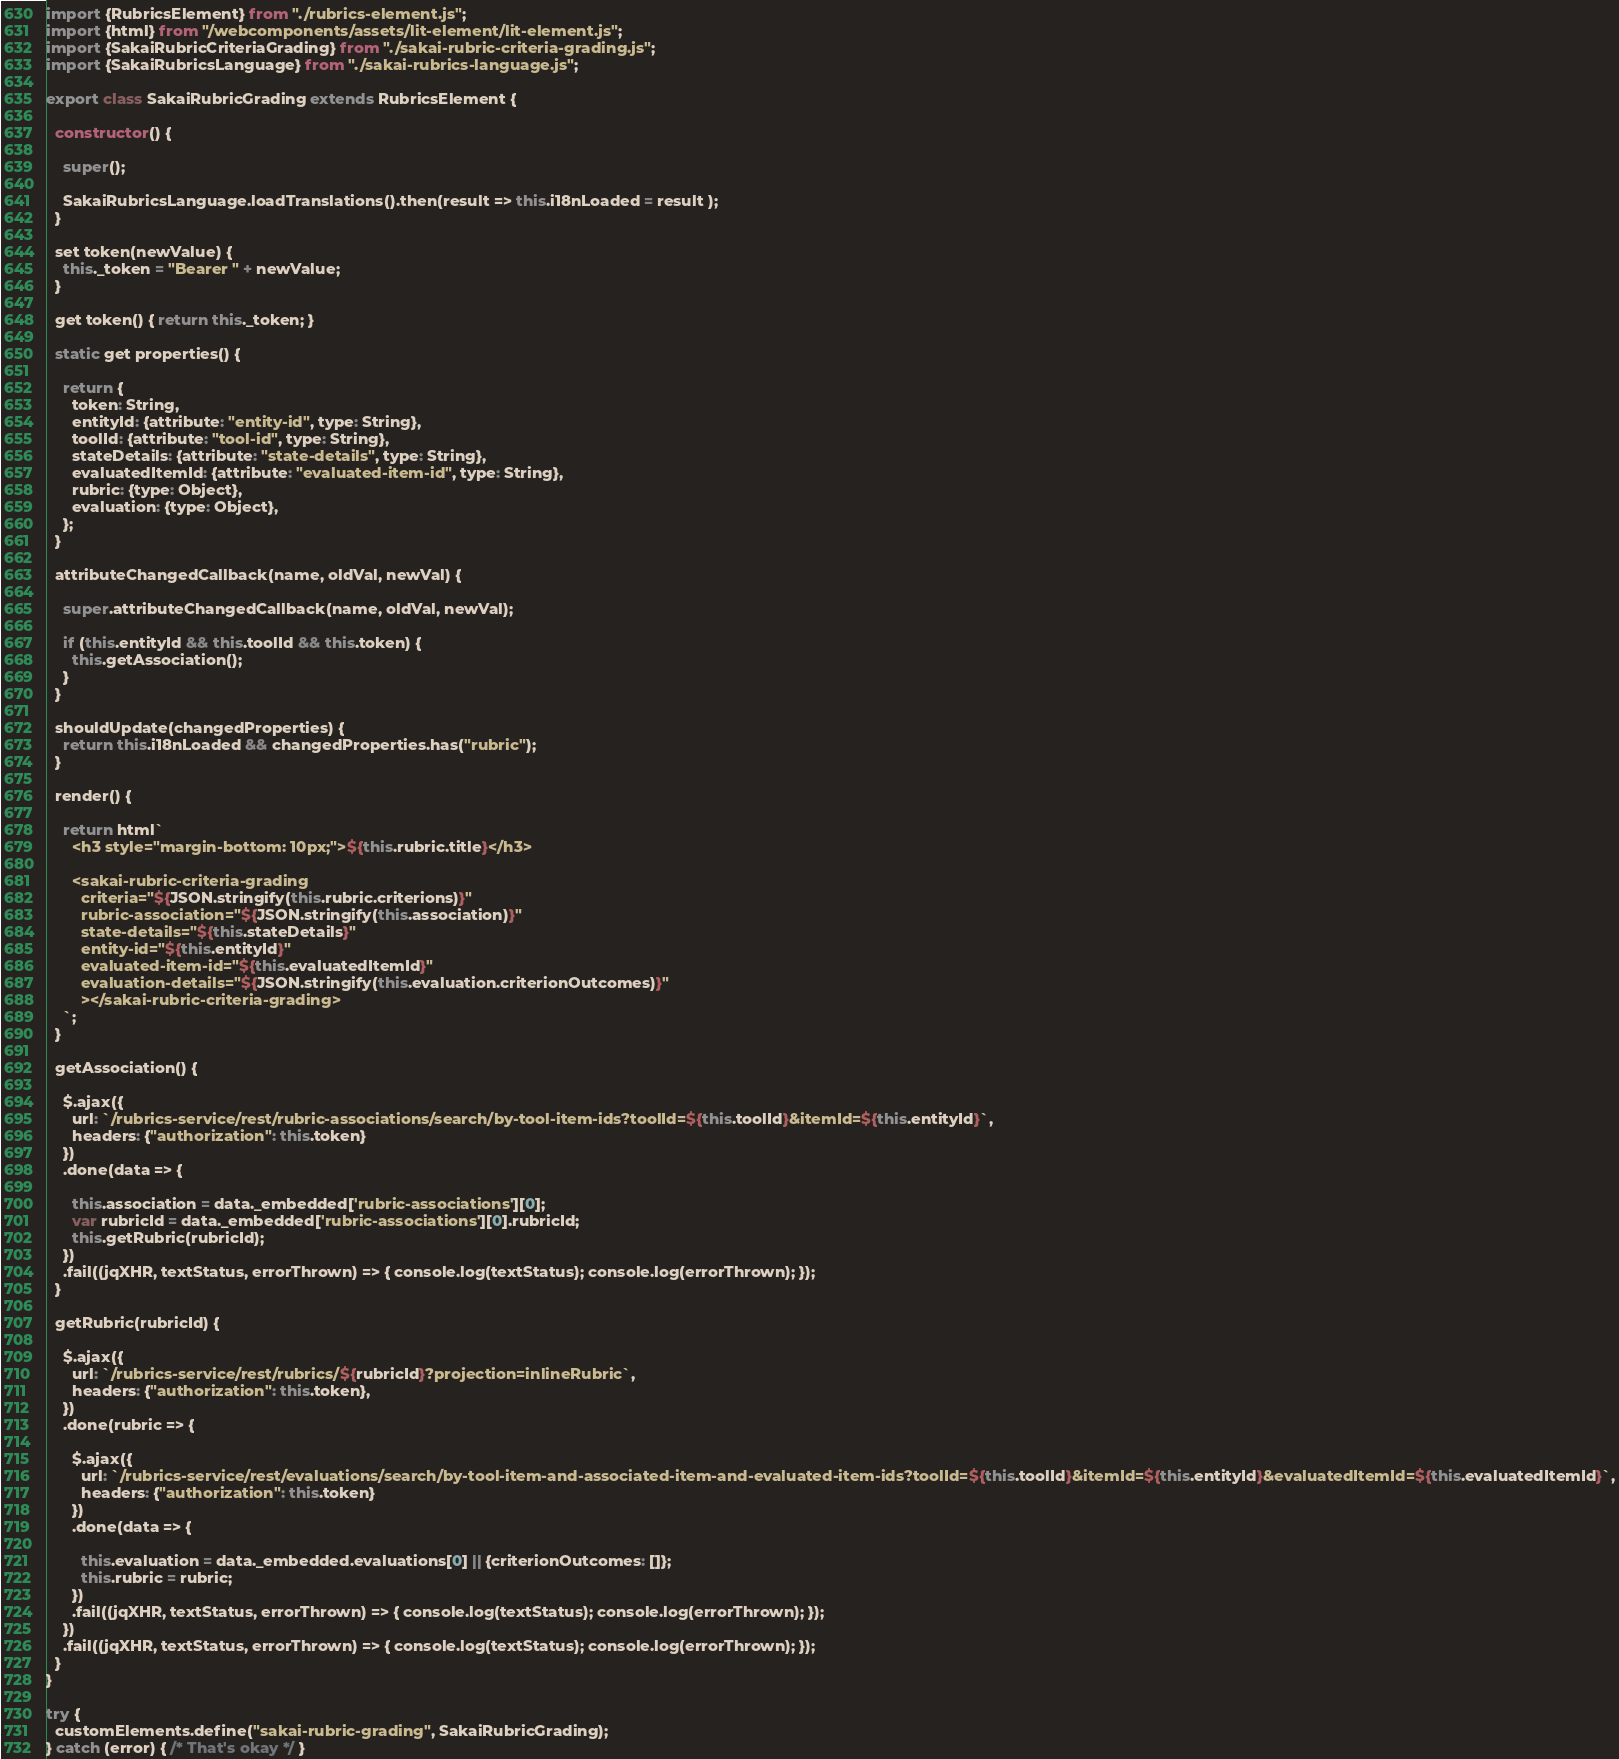Convert code to text. <code><loc_0><loc_0><loc_500><loc_500><_JavaScript_>import {RubricsElement} from "./rubrics-element.js";
import {html} from "/webcomponents/assets/lit-element/lit-element.js";
import {SakaiRubricCriteriaGrading} from "./sakai-rubric-criteria-grading.js";
import {SakaiRubricsLanguage} from "./sakai-rubrics-language.js";

export class SakaiRubricGrading extends RubricsElement {

  constructor() {

    super();

    SakaiRubricsLanguage.loadTranslations().then(result => this.i18nLoaded = result );
  }

  set token(newValue) {
    this._token = "Bearer " + newValue;
  }

  get token() { return this._token; }

  static get properties() {

    return {
      token: String,
      entityId: {attribute: "entity-id", type: String},
      toolId: {attribute: "tool-id", type: String},
      stateDetails: {attribute: "state-details", type: String},
      evaluatedItemId: {attribute: "evaluated-item-id", type: String},
      rubric: {type: Object},
      evaluation: {type: Object},
    };
  }

  attributeChangedCallback(name, oldVal, newVal) {

    super.attributeChangedCallback(name, oldVal, newVal);

    if (this.entityId && this.toolId && this.token) {
      this.getAssociation();
    }
  }

  shouldUpdate(changedProperties) {
    return this.i18nLoaded && changedProperties.has("rubric");
  }

  render() {

    return html`
      <h3 style="margin-bottom: 10px;">${this.rubric.title}</h3>

      <sakai-rubric-criteria-grading
        criteria="${JSON.stringify(this.rubric.criterions)}"
        rubric-association="${JSON.stringify(this.association)}"
        state-details="${this.stateDetails}"
        entity-id="${this.entityId}"
        evaluated-item-id="${this.evaluatedItemId}"
        evaluation-details="${JSON.stringify(this.evaluation.criterionOutcomes)}"
        ></sakai-rubric-criteria-grading>
    `;
  }

  getAssociation() {

    $.ajax({
      url: `/rubrics-service/rest/rubric-associations/search/by-tool-item-ids?toolId=${this.toolId}&itemId=${this.entityId}`,
      headers: {"authorization": this.token}
    })
    .done(data => {

      this.association = data._embedded['rubric-associations'][0];
      var rubricId = data._embedded['rubric-associations'][0].rubricId;
      this.getRubric(rubricId);
    })
    .fail((jqXHR, textStatus, errorThrown) => { console.log(textStatus); console.log(errorThrown); });
  }

  getRubric(rubricId) {

    $.ajax({
      url: `/rubrics-service/rest/rubrics/${rubricId}?projection=inlineRubric`,
      headers: {"authorization": this.token},
    })
    .done(rubric => {

      $.ajax({
        url: `/rubrics-service/rest/evaluations/search/by-tool-item-and-associated-item-and-evaluated-item-ids?toolId=${this.toolId}&itemId=${this.entityId}&evaluatedItemId=${this.evaluatedItemId}`,
        headers: {"authorization": this.token}
      })
      .done(data => {

        this.evaluation = data._embedded.evaluations[0] || {criterionOutcomes: []};
        this.rubric = rubric;
      })
      .fail((jqXHR, textStatus, errorThrown) => { console.log(textStatus); console.log(errorThrown); });
    })
    .fail((jqXHR, textStatus, errorThrown) => { console.log(textStatus); console.log(errorThrown); });
  }
}

try {
  customElements.define("sakai-rubric-grading", SakaiRubricGrading);
} catch (error) { /* That's okay */ }
</code> 